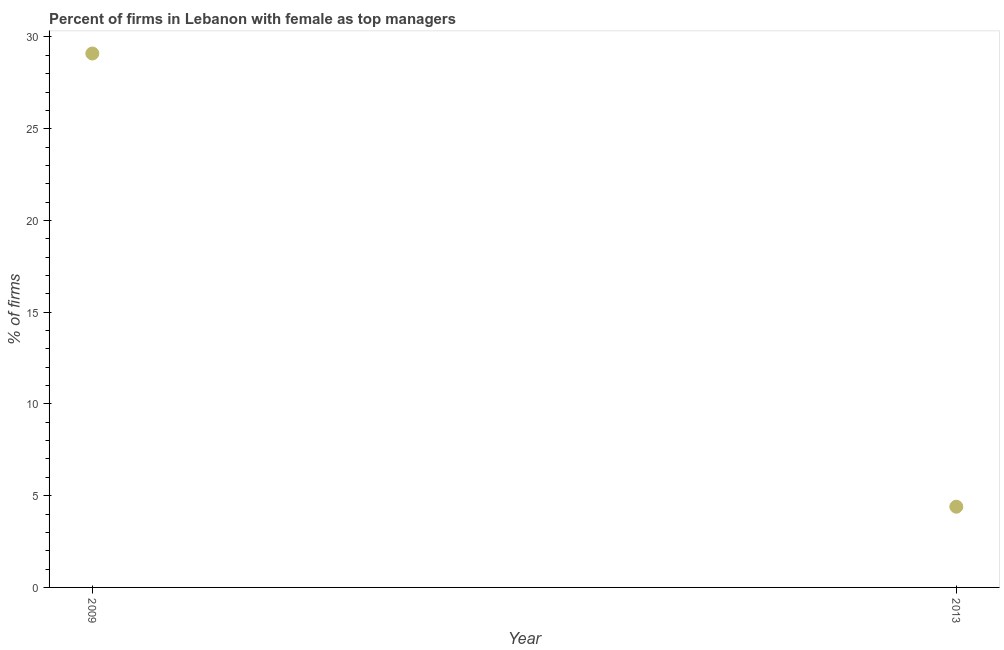What is the percentage of firms with female as top manager in 2013?
Your answer should be very brief. 4.4. Across all years, what is the maximum percentage of firms with female as top manager?
Give a very brief answer. 29.1. In which year was the percentage of firms with female as top manager maximum?
Offer a very short reply. 2009. What is the sum of the percentage of firms with female as top manager?
Ensure brevity in your answer.  33.5. What is the difference between the percentage of firms with female as top manager in 2009 and 2013?
Give a very brief answer. 24.7. What is the average percentage of firms with female as top manager per year?
Make the answer very short. 16.75. What is the median percentage of firms with female as top manager?
Your response must be concise. 16.75. Do a majority of the years between 2009 and 2013 (inclusive) have percentage of firms with female as top manager greater than 25 %?
Ensure brevity in your answer.  No. What is the ratio of the percentage of firms with female as top manager in 2009 to that in 2013?
Ensure brevity in your answer.  6.61. What is the difference between two consecutive major ticks on the Y-axis?
Offer a very short reply. 5. Does the graph contain grids?
Provide a short and direct response. No. What is the title of the graph?
Offer a very short reply. Percent of firms in Lebanon with female as top managers. What is the label or title of the X-axis?
Give a very brief answer. Year. What is the label or title of the Y-axis?
Your response must be concise. % of firms. What is the % of firms in 2009?
Offer a very short reply. 29.1. What is the difference between the % of firms in 2009 and 2013?
Your response must be concise. 24.7. What is the ratio of the % of firms in 2009 to that in 2013?
Your answer should be compact. 6.61. 